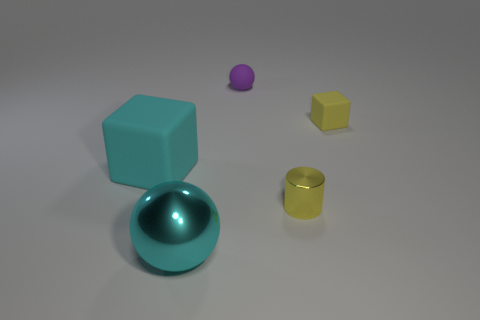What material is the big object that is the same color as the big metal ball?
Offer a very short reply. Rubber. The rubber ball has what size?
Give a very brief answer. Small. Is the number of rubber balls that are in front of the cyan ball greater than the number of large cyan blocks?
Your answer should be very brief. No. Are there the same number of objects behind the big cube and large cyan shiny things that are to the right of the yellow matte object?
Offer a very short reply. No. The object that is both right of the purple matte object and behind the shiny cylinder is what color?
Keep it short and to the point. Yellow. Are there any other things that are the same size as the matte sphere?
Your answer should be very brief. Yes. Are there more tiny blocks that are in front of the metal sphere than blocks behind the tiny purple object?
Ensure brevity in your answer.  No. There is a cube right of the cylinder; is it the same size as the large cyan metal ball?
Ensure brevity in your answer.  No. What number of yellow objects are right of the tiny rubber thing right of the small purple matte ball behind the shiny cylinder?
Offer a terse response. 0. There is a matte object that is both in front of the purple ball and to the left of the cylinder; what is its size?
Offer a terse response. Large. 